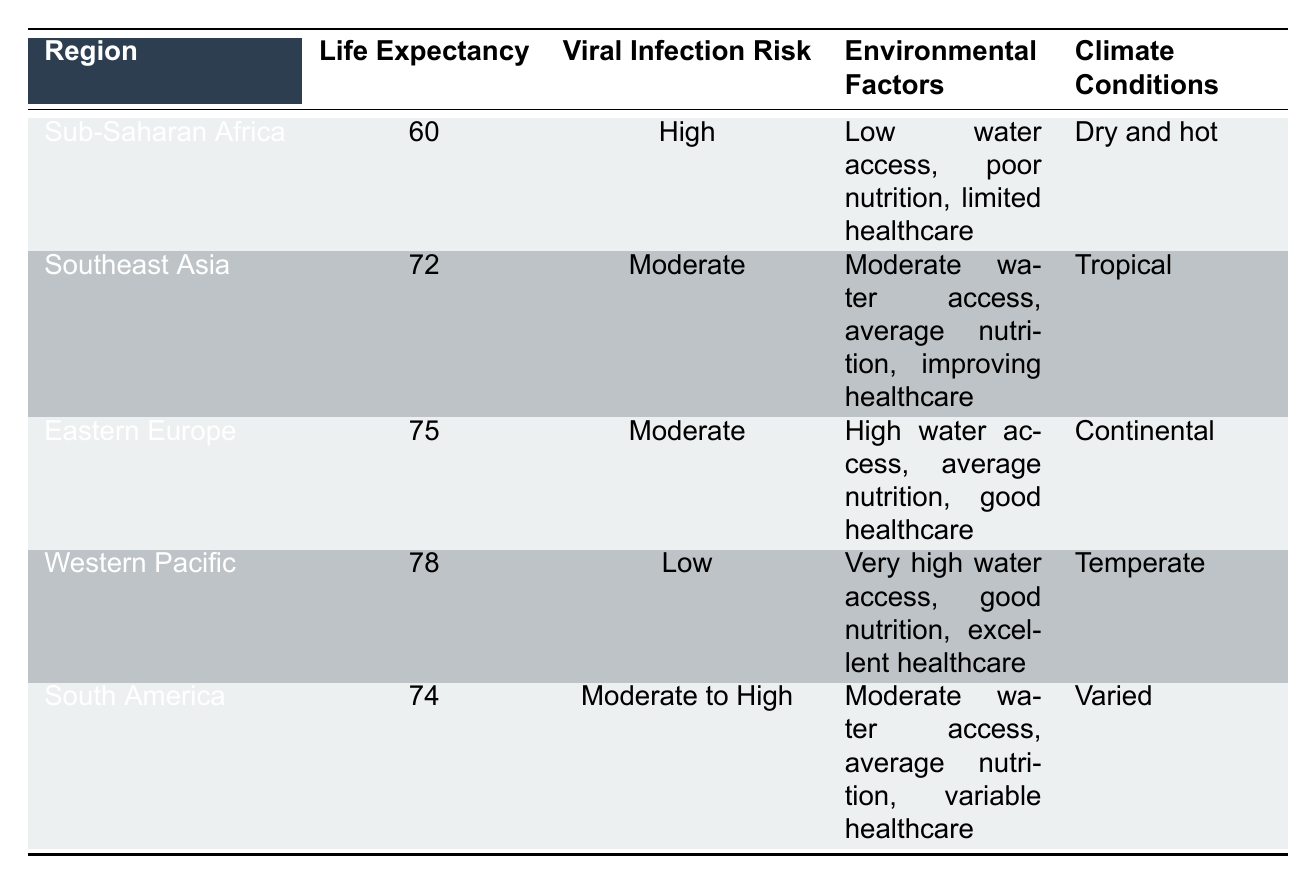What is the average life expectancy in Sub-Saharan Africa? The table shows that the average life expectancy in Sub-Saharan Africa is listed as 60 years.
Answer: 60 Is the viral infection risk in Eastern Europe moderate? The table indicates that Eastern Europe has a viral infection risk labeled as "Moderate."
Answer: Yes Which region has the highest average life expectancy? By comparing the life expectancy values in the table, Western Pacific has the highest life expectancy at 78 years compared to all other regions.
Answer: Western Pacific What is the difference in average life expectancy between the Western Pacific and Sub-Saharan Africa? The average life expectancy in the Western Pacific is 78 years and in Sub-Saharan Africa it is 60 years. Calculating the difference: 78 - 60 = 18 years.
Answer: 18 Do regions with high viral infection risk have lower life expectancy on average compared to those with low or moderate risk? Sub-Saharan Africa with high infection risk has an average life expectancy of 60 years. The regions with moderate (Southeast Asia at 72, Eastern Europe at 75, South America at 74) and low (Western Pacific at 78) viral infection risks have higher life expectancies on average than Sub-Saharan Africa.
Answer: Yes Which environmental factor is characterized as "Very High" in the Western Pacific region? The table specifies that the environmental factor of access to clean water is characterized as "Very High" in the Western Pacific region.
Answer: Access to clean water What is the average life expectancy for regions with moderate viral infection risk? The regions identified with moderate viral infection risk are Southeast Asia (72), Eastern Europe (75), and South America (74). Therefore, the average life expectancy is (72 + 75 + 74) / 3 = 73.67 years when calculated.
Answer: 73.67 Does South America have limited healthcare access according to the table? The table states that South America has variable healthcare access, not limited healthcare access.
Answer: No Which region has the worst access to clean water and how does that correlate with its life expectancy? Sub-Saharan Africa has the worst access to clean water (Low) with an average life expectancy of 60 years. This correlation suggests that lower access to clean water is associated with lower life expectancy.
Answer: Sub-Saharan Africa; 60 years 